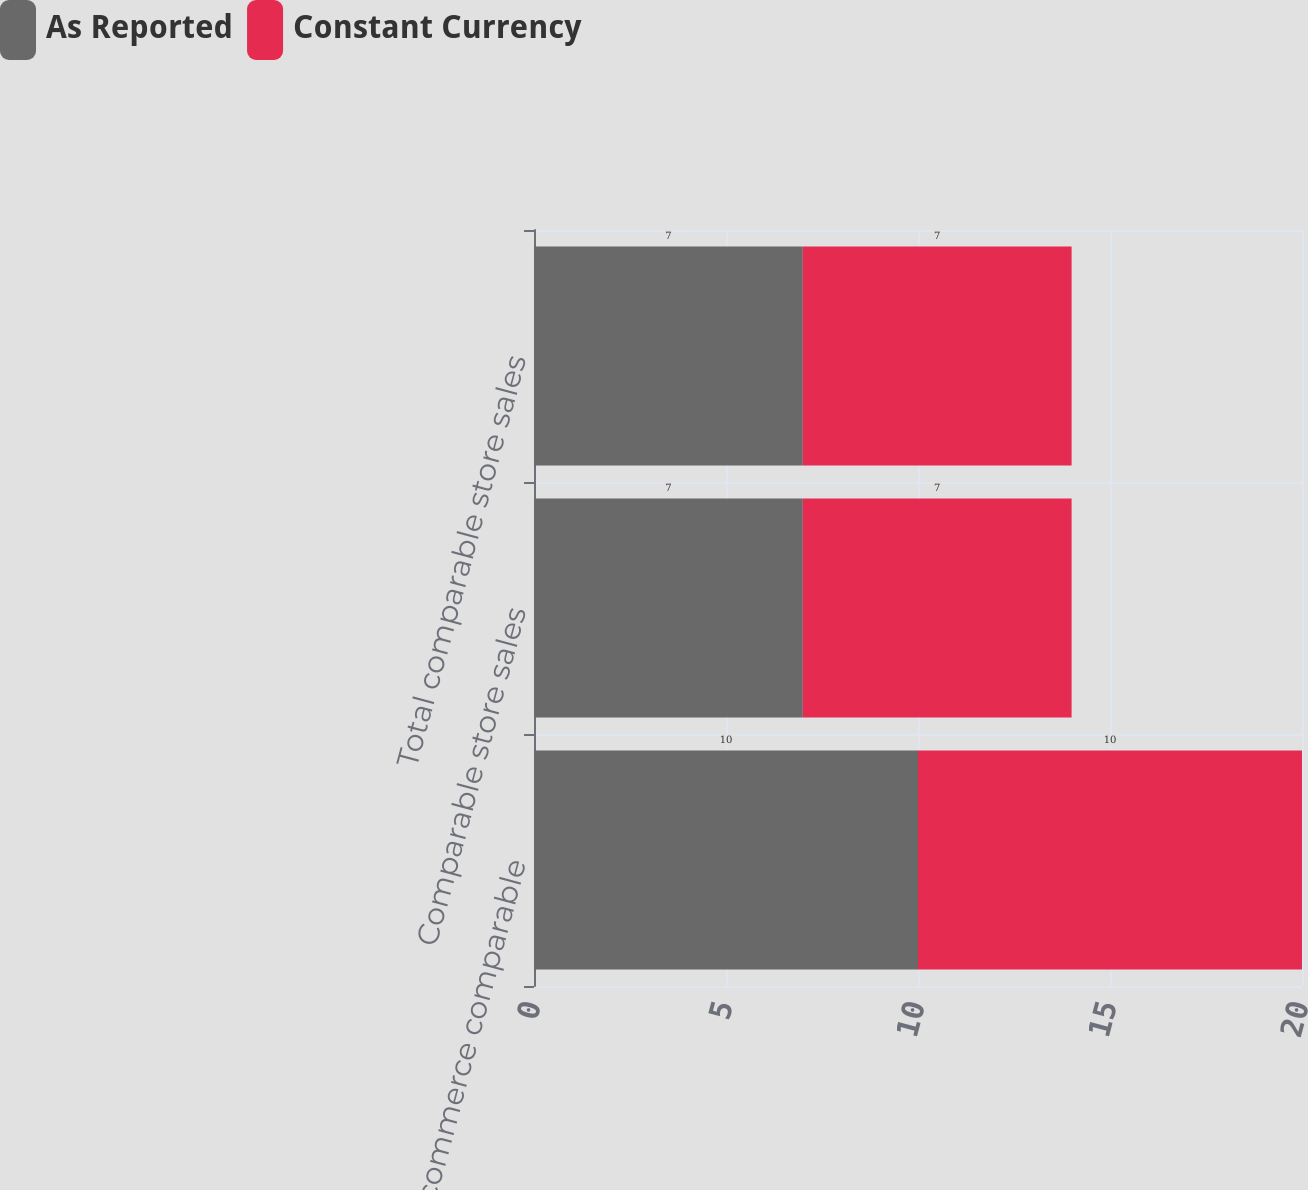Convert chart to OTSL. <chart><loc_0><loc_0><loc_500><loc_500><stacked_bar_chart><ecel><fcel>Digital commerce comparable<fcel>Comparable store sales<fcel>Total comparable store sales<nl><fcel>As Reported<fcel>10<fcel>7<fcel>7<nl><fcel>Constant Currency<fcel>10<fcel>7<fcel>7<nl></chart> 